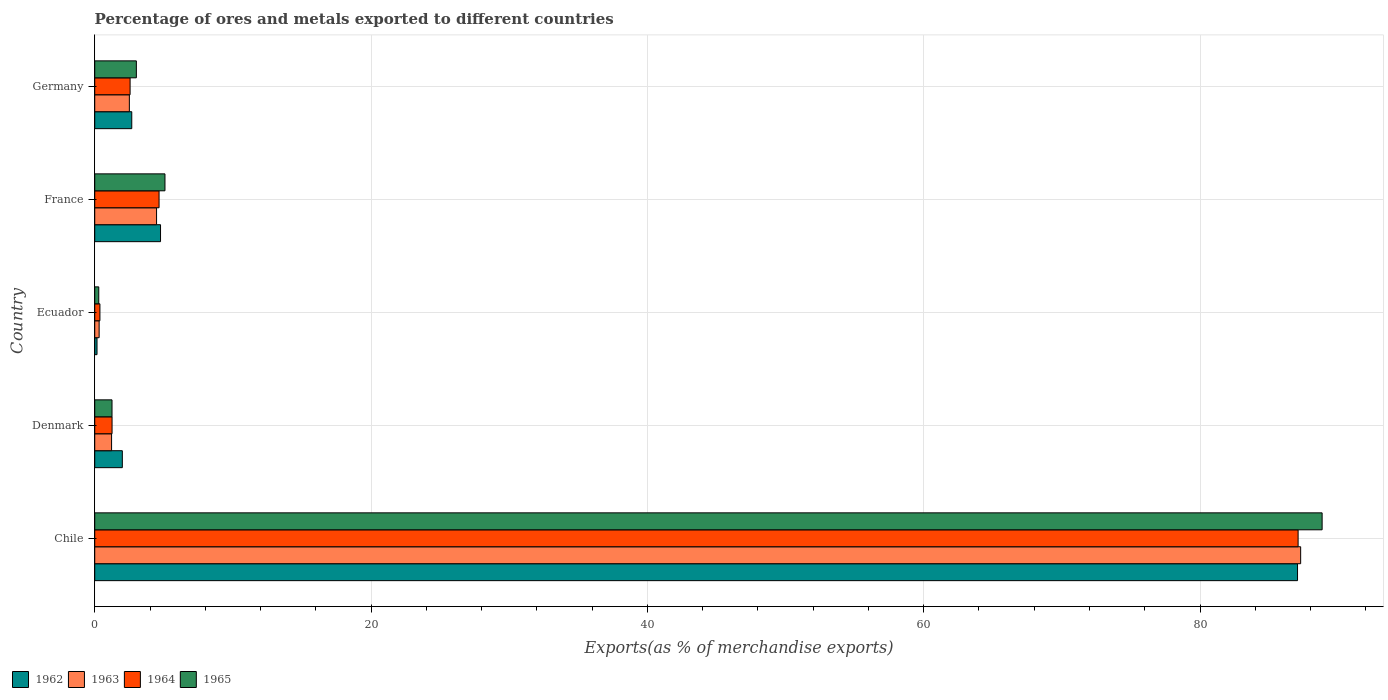Are the number of bars per tick equal to the number of legend labels?
Your response must be concise. Yes. How many bars are there on the 1st tick from the bottom?
Provide a succinct answer. 4. What is the label of the 5th group of bars from the top?
Ensure brevity in your answer.  Chile. In how many cases, is the number of bars for a given country not equal to the number of legend labels?
Make the answer very short. 0. What is the percentage of exports to different countries in 1962 in France?
Your answer should be compact. 4.76. Across all countries, what is the maximum percentage of exports to different countries in 1964?
Your answer should be very brief. 87.1. Across all countries, what is the minimum percentage of exports to different countries in 1964?
Make the answer very short. 0.38. In which country was the percentage of exports to different countries in 1964 minimum?
Keep it short and to the point. Ecuador. What is the total percentage of exports to different countries in 1964 in the graph?
Give a very brief answer. 95.94. What is the difference between the percentage of exports to different countries in 1962 in Denmark and that in Germany?
Ensure brevity in your answer.  -0.68. What is the difference between the percentage of exports to different countries in 1963 in Germany and the percentage of exports to different countries in 1962 in Ecuador?
Offer a terse response. 2.34. What is the average percentage of exports to different countries in 1964 per country?
Ensure brevity in your answer.  19.19. What is the difference between the percentage of exports to different countries in 1964 and percentage of exports to different countries in 1963 in Denmark?
Your answer should be very brief. 0.03. What is the ratio of the percentage of exports to different countries in 1963 in France to that in Germany?
Your answer should be very brief. 1.79. Is the percentage of exports to different countries in 1965 in Ecuador less than that in France?
Provide a succinct answer. Yes. Is the difference between the percentage of exports to different countries in 1964 in Denmark and Germany greater than the difference between the percentage of exports to different countries in 1963 in Denmark and Germany?
Offer a terse response. No. What is the difference between the highest and the second highest percentage of exports to different countries in 1963?
Offer a very short reply. 82.81. What is the difference between the highest and the lowest percentage of exports to different countries in 1962?
Make the answer very short. 86.89. Is it the case that in every country, the sum of the percentage of exports to different countries in 1964 and percentage of exports to different countries in 1962 is greater than the sum of percentage of exports to different countries in 1963 and percentage of exports to different countries in 1965?
Give a very brief answer. No. What does the 4th bar from the top in France represents?
Offer a very short reply. 1962. How many bars are there?
Provide a short and direct response. 20. Are all the bars in the graph horizontal?
Offer a terse response. Yes. Does the graph contain any zero values?
Offer a very short reply. No. How many legend labels are there?
Make the answer very short. 4. What is the title of the graph?
Give a very brief answer. Percentage of ores and metals exported to different countries. What is the label or title of the X-axis?
Provide a short and direct response. Exports(as % of merchandise exports). What is the Exports(as % of merchandise exports) of 1962 in Chile?
Ensure brevity in your answer.  87.06. What is the Exports(as % of merchandise exports) in 1963 in Chile?
Make the answer very short. 87.28. What is the Exports(as % of merchandise exports) of 1964 in Chile?
Your answer should be compact. 87.1. What is the Exports(as % of merchandise exports) of 1965 in Chile?
Your response must be concise. 88.84. What is the Exports(as % of merchandise exports) of 1962 in Denmark?
Your answer should be compact. 2. What is the Exports(as % of merchandise exports) in 1963 in Denmark?
Your answer should be very brief. 1.22. What is the Exports(as % of merchandise exports) of 1964 in Denmark?
Provide a short and direct response. 1.25. What is the Exports(as % of merchandise exports) of 1965 in Denmark?
Your answer should be compact. 1.25. What is the Exports(as % of merchandise exports) of 1962 in Ecuador?
Offer a terse response. 0.17. What is the Exports(as % of merchandise exports) of 1963 in Ecuador?
Give a very brief answer. 0.32. What is the Exports(as % of merchandise exports) of 1964 in Ecuador?
Your answer should be compact. 0.38. What is the Exports(as % of merchandise exports) in 1965 in Ecuador?
Your answer should be compact. 0.29. What is the Exports(as % of merchandise exports) of 1962 in France?
Provide a short and direct response. 4.76. What is the Exports(as % of merchandise exports) of 1963 in France?
Your response must be concise. 4.48. What is the Exports(as % of merchandise exports) in 1964 in France?
Your response must be concise. 4.66. What is the Exports(as % of merchandise exports) of 1965 in France?
Offer a very short reply. 5.08. What is the Exports(as % of merchandise exports) of 1962 in Germany?
Your response must be concise. 2.68. What is the Exports(as % of merchandise exports) of 1963 in Germany?
Make the answer very short. 2.51. What is the Exports(as % of merchandise exports) in 1964 in Germany?
Your answer should be compact. 2.56. What is the Exports(as % of merchandise exports) of 1965 in Germany?
Your answer should be compact. 3.01. Across all countries, what is the maximum Exports(as % of merchandise exports) of 1962?
Your answer should be very brief. 87.06. Across all countries, what is the maximum Exports(as % of merchandise exports) of 1963?
Your answer should be compact. 87.28. Across all countries, what is the maximum Exports(as % of merchandise exports) in 1964?
Provide a succinct answer. 87.1. Across all countries, what is the maximum Exports(as % of merchandise exports) of 1965?
Your response must be concise. 88.84. Across all countries, what is the minimum Exports(as % of merchandise exports) of 1962?
Make the answer very short. 0.17. Across all countries, what is the minimum Exports(as % of merchandise exports) in 1963?
Offer a very short reply. 0.32. Across all countries, what is the minimum Exports(as % of merchandise exports) in 1964?
Keep it short and to the point. 0.38. Across all countries, what is the minimum Exports(as % of merchandise exports) in 1965?
Make the answer very short. 0.29. What is the total Exports(as % of merchandise exports) of 1962 in the graph?
Ensure brevity in your answer.  96.66. What is the total Exports(as % of merchandise exports) of 1963 in the graph?
Provide a succinct answer. 95.8. What is the total Exports(as % of merchandise exports) of 1964 in the graph?
Ensure brevity in your answer.  95.94. What is the total Exports(as % of merchandise exports) of 1965 in the graph?
Provide a succinct answer. 98.47. What is the difference between the Exports(as % of merchandise exports) of 1962 in Chile and that in Denmark?
Offer a terse response. 85.06. What is the difference between the Exports(as % of merchandise exports) in 1963 in Chile and that in Denmark?
Provide a succinct answer. 86.06. What is the difference between the Exports(as % of merchandise exports) of 1964 in Chile and that in Denmark?
Provide a succinct answer. 85.84. What is the difference between the Exports(as % of merchandise exports) in 1965 in Chile and that in Denmark?
Ensure brevity in your answer.  87.58. What is the difference between the Exports(as % of merchandise exports) of 1962 in Chile and that in Ecuador?
Make the answer very short. 86.89. What is the difference between the Exports(as % of merchandise exports) in 1963 in Chile and that in Ecuador?
Provide a succinct answer. 86.96. What is the difference between the Exports(as % of merchandise exports) in 1964 in Chile and that in Ecuador?
Offer a very short reply. 86.72. What is the difference between the Exports(as % of merchandise exports) in 1965 in Chile and that in Ecuador?
Offer a terse response. 88.54. What is the difference between the Exports(as % of merchandise exports) of 1962 in Chile and that in France?
Provide a succinct answer. 82.29. What is the difference between the Exports(as % of merchandise exports) in 1963 in Chile and that in France?
Your response must be concise. 82.81. What is the difference between the Exports(as % of merchandise exports) in 1964 in Chile and that in France?
Give a very brief answer. 82.44. What is the difference between the Exports(as % of merchandise exports) of 1965 in Chile and that in France?
Make the answer very short. 83.75. What is the difference between the Exports(as % of merchandise exports) in 1962 in Chile and that in Germany?
Provide a short and direct response. 84.37. What is the difference between the Exports(as % of merchandise exports) in 1963 in Chile and that in Germany?
Your response must be concise. 84.78. What is the difference between the Exports(as % of merchandise exports) of 1964 in Chile and that in Germany?
Make the answer very short. 84.54. What is the difference between the Exports(as % of merchandise exports) in 1965 in Chile and that in Germany?
Provide a succinct answer. 85.82. What is the difference between the Exports(as % of merchandise exports) of 1962 in Denmark and that in Ecuador?
Your answer should be very brief. 1.83. What is the difference between the Exports(as % of merchandise exports) of 1963 in Denmark and that in Ecuador?
Make the answer very short. 0.9. What is the difference between the Exports(as % of merchandise exports) of 1964 in Denmark and that in Ecuador?
Your answer should be compact. 0.88. What is the difference between the Exports(as % of merchandise exports) of 1965 in Denmark and that in Ecuador?
Give a very brief answer. 0.96. What is the difference between the Exports(as % of merchandise exports) in 1962 in Denmark and that in France?
Give a very brief answer. -2.76. What is the difference between the Exports(as % of merchandise exports) in 1963 in Denmark and that in France?
Ensure brevity in your answer.  -3.26. What is the difference between the Exports(as % of merchandise exports) in 1964 in Denmark and that in France?
Offer a terse response. -3.4. What is the difference between the Exports(as % of merchandise exports) in 1965 in Denmark and that in France?
Ensure brevity in your answer.  -3.83. What is the difference between the Exports(as % of merchandise exports) in 1962 in Denmark and that in Germany?
Make the answer very short. -0.68. What is the difference between the Exports(as % of merchandise exports) of 1963 in Denmark and that in Germany?
Your response must be concise. -1.29. What is the difference between the Exports(as % of merchandise exports) of 1964 in Denmark and that in Germany?
Your response must be concise. -1.31. What is the difference between the Exports(as % of merchandise exports) in 1965 in Denmark and that in Germany?
Ensure brevity in your answer.  -1.76. What is the difference between the Exports(as % of merchandise exports) in 1962 in Ecuador and that in France?
Ensure brevity in your answer.  -4.6. What is the difference between the Exports(as % of merchandise exports) of 1963 in Ecuador and that in France?
Offer a very short reply. -4.16. What is the difference between the Exports(as % of merchandise exports) of 1964 in Ecuador and that in France?
Ensure brevity in your answer.  -4.28. What is the difference between the Exports(as % of merchandise exports) of 1965 in Ecuador and that in France?
Keep it short and to the point. -4.79. What is the difference between the Exports(as % of merchandise exports) in 1962 in Ecuador and that in Germany?
Your answer should be compact. -2.51. What is the difference between the Exports(as % of merchandise exports) in 1963 in Ecuador and that in Germany?
Ensure brevity in your answer.  -2.19. What is the difference between the Exports(as % of merchandise exports) in 1964 in Ecuador and that in Germany?
Your answer should be very brief. -2.18. What is the difference between the Exports(as % of merchandise exports) of 1965 in Ecuador and that in Germany?
Offer a terse response. -2.72. What is the difference between the Exports(as % of merchandise exports) of 1962 in France and that in Germany?
Keep it short and to the point. 2.08. What is the difference between the Exports(as % of merchandise exports) in 1963 in France and that in Germany?
Ensure brevity in your answer.  1.97. What is the difference between the Exports(as % of merchandise exports) in 1964 in France and that in Germany?
Provide a short and direct response. 2.1. What is the difference between the Exports(as % of merchandise exports) in 1965 in France and that in Germany?
Ensure brevity in your answer.  2.07. What is the difference between the Exports(as % of merchandise exports) in 1962 in Chile and the Exports(as % of merchandise exports) in 1963 in Denmark?
Your answer should be compact. 85.84. What is the difference between the Exports(as % of merchandise exports) of 1962 in Chile and the Exports(as % of merchandise exports) of 1964 in Denmark?
Provide a short and direct response. 85.8. What is the difference between the Exports(as % of merchandise exports) of 1962 in Chile and the Exports(as % of merchandise exports) of 1965 in Denmark?
Your response must be concise. 85.8. What is the difference between the Exports(as % of merchandise exports) of 1963 in Chile and the Exports(as % of merchandise exports) of 1964 in Denmark?
Ensure brevity in your answer.  86.03. What is the difference between the Exports(as % of merchandise exports) of 1963 in Chile and the Exports(as % of merchandise exports) of 1965 in Denmark?
Ensure brevity in your answer.  86.03. What is the difference between the Exports(as % of merchandise exports) of 1964 in Chile and the Exports(as % of merchandise exports) of 1965 in Denmark?
Your answer should be compact. 85.85. What is the difference between the Exports(as % of merchandise exports) in 1962 in Chile and the Exports(as % of merchandise exports) in 1963 in Ecuador?
Your answer should be very brief. 86.74. What is the difference between the Exports(as % of merchandise exports) in 1962 in Chile and the Exports(as % of merchandise exports) in 1964 in Ecuador?
Your answer should be compact. 86.68. What is the difference between the Exports(as % of merchandise exports) in 1962 in Chile and the Exports(as % of merchandise exports) in 1965 in Ecuador?
Provide a succinct answer. 86.76. What is the difference between the Exports(as % of merchandise exports) in 1963 in Chile and the Exports(as % of merchandise exports) in 1964 in Ecuador?
Provide a succinct answer. 86.91. What is the difference between the Exports(as % of merchandise exports) in 1963 in Chile and the Exports(as % of merchandise exports) in 1965 in Ecuador?
Keep it short and to the point. 86.99. What is the difference between the Exports(as % of merchandise exports) of 1964 in Chile and the Exports(as % of merchandise exports) of 1965 in Ecuador?
Make the answer very short. 86.81. What is the difference between the Exports(as % of merchandise exports) of 1962 in Chile and the Exports(as % of merchandise exports) of 1963 in France?
Your answer should be compact. 82.58. What is the difference between the Exports(as % of merchandise exports) of 1962 in Chile and the Exports(as % of merchandise exports) of 1964 in France?
Make the answer very short. 82.4. What is the difference between the Exports(as % of merchandise exports) in 1962 in Chile and the Exports(as % of merchandise exports) in 1965 in France?
Provide a succinct answer. 81.97. What is the difference between the Exports(as % of merchandise exports) of 1963 in Chile and the Exports(as % of merchandise exports) of 1964 in France?
Provide a succinct answer. 82.63. What is the difference between the Exports(as % of merchandise exports) of 1963 in Chile and the Exports(as % of merchandise exports) of 1965 in France?
Ensure brevity in your answer.  82.2. What is the difference between the Exports(as % of merchandise exports) in 1964 in Chile and the Exports(as % of merchandise exports) in 1965 in France?
Keep it short and to the point. 82.01. What is the difference between the Exports(as % of merchandise exports) in 1962 in Chile and the Exports(as % of merchandise exports) in 1963 in Germany?
Offer a very short reply. 84.55. What is the difference between the Exports(as % of merchandise exports) of 1962 in Chile and the Exports(as % of merchandise exports) of 1964 in Germany?
Offer a terse response. 84.5. What is the difference between the Exports(as % of merchandise exports) in 1962 in Chile and the Exports(as % of merchandise exports) in 1965 in Germany?
Your response must be concise. 84.04. What is the difference between the Exports(as % of merchandise exports) of 1963 in Chile and the Exports(as % of merchandise exports) of 1964 in Germany?
Ensure brevity in your answer.  84.72. What is the difference between the Exports(as % of merchandise exports) in 1963 in Chile and the Exports(as % of merchandise exports) in 1965 in Germany?
Your response must be concise. 84.27. What is the difference between the Exports(as % of merchandise exports) in 1964 in Chile and the Exports(as % of merchandise exports) in 1965 in Germany?
Provide a short and direct response. 84.08. What is the difference between the Exports(as % of merchandise exports) in 1962 in Denmark and the Exports(as % of merchandise exports) in 1963 in Ecuador?
Keep it short and to the point. 1.68. What is the difference between the Exports(as % of merchandise exports) in 1962 in Denmark and the Exports(as % of merchandise exports) in 1964 in Ecuador?
Your answer should be compact. 1.62. What is the difference between the Exports(as % of merchandise exports) in 1962 in Denmark and the Exports(as % of merchandise exports) in 1965 in Ecuador?
Offer a very short reply. 1.71. What is the difference between the Exports(as % of merchandise exports) in 1963 in Denmark and the Exports(as % of merchandise exports) in 1964 in Ecuador?
Offer a terse response. 0.84. What is the difference between the Exports(as % of merchandise exports) in 1963 in Denmark and the Exports(as % of merchandise exports) in 1965 in Ecuador?
Offer a terse response. 0.93. What is the difference between the Exports(as % of merchandise exports) of 1964 in Denmark and the Exports(as % of merchandise exports) of 1965 in Ecuador?
Give a very brief answer. 0.96. What is the difference between the Exports(as % of merchandise exports) in 1962 in Denmark and the Exports(as % of merchandise exports) in 1963 in France?
Keep it short and to the point. -2.48. What is the difference between the Exports(as % of merchandise exports) of 1962 in Denmark and the Exports(as % of merchandise exports) of 1964 in France?
Ensure brevity in your answer.  -2.66. What is the difference between the Exports(as % of merchandise exports) of 1962 in Denmark and the Exports(as % of merchandise exports) of 1965 in France?
Ensure brevity in your answer.  -3.09. What is the difference between the Exports(as % of merchandise exports) in 1963 in Denmark and the Exports(as % of merchandise exports) in 1964 in France?
Provide a succinct answer. -3.44. What is the difference between the Exports(as % of merchandise exports) in 1963 in Denmark and the Exports(as % of merchandise exports) in 1965 in France?
Give a very brief answer. -3.86. What is the difference between the Exports(as % of merchandise exports) in 1964 in Denmark and the Exports(as % of merchandise exports) in 1965 in France?
Keep it short and to the point. -3.83. What is the difference between the Exports(as % of merchandise exports) in 1962 in Denmark and the Exports(as % of merchandise exports) in 1963 in Germany?
Provide a short and direct response. -0.51. What is the difference between the Exports(as % of merchandise exports) of 1962 in Denmark and the Exports(as % of merchandise exports) of 1964 in Germany?
Your answer should be compact. -0.56. What is the difference between the Exports(as % of merchandise exports) in 1962 in Denmark and the Exports(as % of merchandise exports) in 1965 in Germany?
Your answer should be compact. -1.02. What is the difference between the Exports(as % of merchandise exports) in 1963 in Denmark and the Exports(as % of merchandise exports) in 1964 in Germany?
Your answer should be compact. -1.34. What is the difference between the Exports(as % of merchandise exports) in 1963 in Denmark and the Exports(as % of merchandise exports) in 1965 in Germany?
Your response must be concise. -1.79. What is the difference between the Exports(as % of merchandise exports) in 1964 in Denmark and the Exports(as % of merchandise exports) in 1965 in Germany?
Provide a succinct answer. -1.76. What is the difference between the Exports(as % of merchandise exports) of 1962 in Ecuador and the Exports(as % of merchandise exports) of 1963 in France?
Provide a short and direct response. -4.31. What is the difference between the Exports(as % of merchandise exports) of 1962 in Ecuador and the Exports(as % of merchandise exports) of 1964 in France?
Keep it short and to the point. -4.49. What is the difference between the Exports(as % of merchandise exports) of 1962 in Ecuador and the Exports(as % of merchandise exports) of 1965 in France?
Your response must be concise. -4.92. What is the difference between the Exports(as % of merchandise exports) in 1963 in Ecuador and the Exports(as % of merchandise exports) in 1964 in France?
Offer a very short reply. -4.34. What is the difference between the Exports(as % of merchandise exports) of 1963 in Ecuador and the Exports(as % of merchandise exports) of 1965 in France?
Keep it short and to the point. -4.76. What is the difference between the Exports(as % of merchandise exports) of 1964 in Ecuador and the Exports(as % of merchandise exports) of 1965 in France?
Keep it short and to the point. -4.71. What is the difference between the Exports(as % of merchandise exports) in 1962 in Ecuador and the Exports(as % of merchandise exports) in 1963 in Germany?
Provide a succinct answer. -2.34. What is the difference between the Exports(as % of merchandise exports) in 1962 in Ecuador and the Exports(as % of merchandise exports) in 1964 in Germany?
Ensure brevity in your answer.  -2.39. What is the difference between the Exports(as % of merchandise exports) of 1962 in Ecuador and the Exports(as % of merchandise exports) of 1965 in Germany?
Provide a short and direct response. -2.85. What is the difference between the Exports(as % of merchandise exports) of 1963 in Ecuador and the Exports(as % of merchandise exports) of 1964 in Germany?
Offer a terse response. -2.24. What is the difference between the Exports(as % of merchandise exports) in 1963 in Ecuador and the Exports(as % of merchandise exports) in 1965 in Germany?
Provide a succinct answer. -2.69. What is the difference between the Exports(as % of merchandise exports) of 1964 in Ecuador and the Exports(as % of merchandise exports) of 1965 in Germany?
Offer a terse response. -2.64. What is the difference between the Exports(as % of merchandise exports) in 1962 in France and the Exports(as % of merchandise exports) in 1963 in Germany?
Keep it short and to the point. 2.26. What is the difference between the Exports(as % of merchandise exports) in 1962 in France and the Exports(as % of merchandise exports) in 1964 in Germany?
Give a very brief answer. 2.2. What is the difference between the Exports(as % of merchandise exports) of 1962 in France and the Exports(as % of merchandise exports) of 1965 in Germany?
Make the answer very short. 1.75. What is the difference between the Exports(as % of merchandise exports) in 1963 in France and the Exports(as % of merchandise exports) in 1964 in Germany?
Your response must be concise. 1.92. What is the difference between the Exports(as % of merchandise exports) in 1963 in France and the Exports(as % of merchandise exports) in 1965 in Germany?
Offer a terse response. 1.46. What is the difference between the Exports(as % of merchandise exports) of 1964 in France and the Exports(as % of merchandise exports) of 1965 in Germany?
Provide a short and direct response. 1.64. What is the average Exports(as % of merchandise exports) in 1962 per country?
Offer a terse response. 19.33. What is the average Exports(as % of merchandise exports) in 1963 per country?
Keep it short and to the point. 19.16. What is the average Exports(as % of merchandise exports) in 1964 per country?
Provide a short and direct response. 19.19. What is the average Exports(as % of merchandise exports) in 1965 per country?
Your answer should be very brief. 19.7. What is the difference between the Exports(as % of merchandise exports) of 1962 and Exports(as % of merchandise exports) of 1963 in Chile?
Your answer should be compact. -0.23. What is the difference between the Exports(as % of merchandise exports) of 1962 and Exports(as % of merchandise exports) of 1964 in Chile?
Ensure brevity in your answer.  -0.04. What is the difference between the Exports(as % of merchandise exports) in 1962 and Exports(as % of merchandise exports) in 1965 in Chile?
Your response must be concise. -1.78. What is the difference between the Exports(as % of merchandise exports) of 1963 and Exports(as % of merchandise exports) of 1964 in Chile?
Offer a very short reply. 0.18. What is the difference between the Exports(as % of merchandise exports) of 1963 and Exports(as % of merchandise exports) of 1965 in Chile?
Your answer should be very brief. -1.55. What is the difference between the Exports(as % of merchandise exports) of 1964 and Exports(as % of merchandise exports) of 1965 in Chile?
Make the answer very short. -1.74. What is the difference between the Exports(as % of merchandise exports) of 1962 and Exports(as % of merchandise exports) of 1963 in Denmark?
Your answer should be very brief. 0.78. What is the difference between the Exports(as % of merchandise exports) of 1962 and Exports(as % of merchandise exports) of 1964 in Denmark?
Your answer should be compact. 0.74. What is the difference between the Exports(as % of merchandise exports) in 1962 and Exports(as % of merchandise exports) in 1965 in Denmark?
Provide a short and direct response. 0.75. What is the difference between the Exports(as % of merchandise exports) in 1963 and Exports(as % of merchandise exports) in 1964 in Denmark?
Provide a short and direct response. -0.03. What is the difference between the Exports(as % of merchandise exports) in 1963 and Exports(as % of merchandise exports) in 1965 in Denmark?
Your answer should be very brief. -0.03. What is the difference between the Exports(as % of merchandise exports) of 1964 and Exports(as % of merchandise exports) of 1965 in Denmark?
Offer a very short reply. 0. What is the difference between the Exports(as % of merchandise exports) of 1962 and Exports(as % of merchandise exports) of 1963 in Ecuador?
Your answer should be compact. -0.15. What is the difference between the Exports(as % of merchandise exports) of 1962 and Exports(as % of merchandise exports) of 1964 in Ecuador?
Keep it short and to the point. -0.21. What is the difference between the Exports(as % of merchandise exports) in 1962 and Exports(as % of merchandise exports) in 1965 in Ecuador?
Make the answer very short. -0.13. What is the difference between the Exports(as % of merchandise exports) of 1963 and Exports(as % of merchandise exports) of 1964 in Ecuador?
Give a very brief answer. -0.06. What is the difference between the Exports(as % of merchandise exports) in 1963 and Exports(as % of merchandise exports) in 1965 in Ecuador?
Keep it short and to the point. 0.03. What is the difference between the Exports(as % of merchandise exports) of 1964 and Exports(as % of merchandise exports) of 1965 in Ecuador?
Keep it short and to the point. 0.08. What is the difference between the Exports(as % of merchandise exports) in 1962 and Exports(as % of merchandise exports) in 1963 in France?
Your answer should be compact. 0.29. What is the difference between the Exports(as % of merchandise exports) in 1962 and Exports(as % of merchandise exports) in 1964 in France?
Give a very brief answer. 0.11. What is the difference between the Exports(as % of merchandise exports) in 1962 and Exports(as % of merchandise exports) in 1965 in France?
Offer a terse response. -0.32. What is the difference between the Exports(as % of merchandise exports) in 1963 and Exports(as % of merchandise exports) in 1964 in France?
Your response must be concise. -0.18. What is the difference between the Exports(as % of merchandise exports) in 1963 and Exports(as % of merchandise exports) in 1965 in France?
Offer a terse response. -0.61. What is the difference between the Exports(as % of merchandise exports) of 1964 and Exports(as % of merchandise exports) of 1965 in France?
Offer a terse response. -0.43. What is the difference between the Exports(as % of merchandise exports) in 1962 and Exports(as % of merchandise exports) in 1963 in Germany?
Keep it short and to the point. 0.17. What is the difference between the Exports(as % of merchandise exports) in 1962 and Exports(as % of merchandise exports) in 1964 in Germany?
Give a very brief answer. 0.12. What is the difference between the Exports(as % of merchandise exports) of 1962 and Exports(as % of merchandise exports) of 1965 in Germany?
Provide a short and direct response. -0.33. What is the difference between the Exports(as % of merchandise exports) of 1963 and Exports(as % of merchandise exports) of 1964 in Germany?
Provide a short and direct response. -0.05. What is the difference between the Exports(as % of merchandise exports) of 1963 and Exports(as % of merchandise exports) of 1965 in Germany?
Your answer should be compact. -0.51. What is the difference between the Exports(as % of merchandise exports) of 1964 and Exports(as % of merchandise exports) of 1965 in Germany?
Provide a succinct answer. -0.45. What is the ratio of the Exports(as % of merchandise exports) in 1962 in Chile to that in Denmark?
Your answer should be very brief. 43.58. What is the ratio of the Exports(as % of merchandise exports) in 1963 in Chile to that in Denmark?
Your response must be concise. 71.57. What is the ratio of the Exports(as % of merchandise exports) of 1964 in Chile to that in Denmark?
Ensure brevity in your answer.  69.44. What is the ratio of the Exports(as % of merchandise exports) of 1965 in Chile to that in Denmark?
Provide a succinct answer. 71. What is the ratio of the Exports(as % of merchandise exports) in 1962 in Chile to that in Ecuador?
Keep it short and to the point. 525.05. What is the ratio of the Exports(as % of merchandise exports) in 1963 in Chile to that in Ecuador?
Give a very brief answer. 273.43. What is the ratio of the Exports(as % of merchandise exports) of 1964 in Chile to that in Ecuador?
Offer a terse response. 231.84. What is the ratio of the Exports(as % of merchandise exports) of 1965 in Chile to that in Ecuador?
Provide a succinct answer. 304.49. What is the ratio of the Exports(as % of merchandise exports) in 1962 in Chile to that in France?
Provide a succinct answer. 18.28. What is the ratio of the Exports(as % of merchandise exports) of 1963 in Chile to that in France?
Your answer should be very brief. 19.5. What is the ratio of the Exports(as % of merchandise exports) of 1964 in Chile to that in France?
Provide a succinct answer. 18.71. What is the ratio of the Exports(as % of merchandise exports) of 1965 in Chile to that in France?
Offer a terse response. 17.47. What is the ratio of the Exports(as % of merchandise exports) in 1962 in Chile to that in Germany?
Ensure brevity in your answer.  32.48. What is the ratio of the Exports(as % of merchandise exports) in 1963 in Chile to that in Germany?
Your response must be concise. 34.83. What is the ratio of the Exports(as % of merchandise exports) in 1964 in Chile to that in Germany?
Provide a short and direct response. 34.03. What is the ratio of the Exports(as % of merchandise exports) of 1965 in Chile to that in Germany?
Give a very brief answer. 29.48. What is the ratio of the Exports(as % of merchandise exports) of 1962 in Denmark to that in Ecuador?
Keep it short and to the point. 12.05. What is the ratio of the Exports(as % of merchandise exports) in 1963 in Denmark to that in Ecuador?
Keep it short and to the point. 3.82. What is the ratio of the Exports(as % of merchandise exports) of 1964 in Denmark to that in Ecuador?
Ensure brevity in your answer.  3.34. What is the ratio of the Exports(as % of merchandise exports) of 1965 in Denmark to that in Ecuador?
Provide a succinct answer. 4.29. What is the ratio of the Exports(as % of merchandise exports) of 1962 in Denmark to that in France?
Make the answer very short. 0.42. What is the ratio of the Exports(as % of merchandise exports) of 1963 in Denmark to that in France?
Provide a succinct answer. 0.27. What is the ratio of the Exports(as % of merchandise exports) of 1964 in Denmark to that in France?
Your answer should be compact. 0.27. What is the ratio of the Exports(as % of merchandise exports) of 1965 in Denmark to that in France?
Provide a short and direct response. 0.25. What is the ratio of the Exports(as % of merchandise exports) of 1962 in Denmark to that in Germany?
Provide a succinct answer. 0.75. What is the ratio of the Exports(as % of merchandise exports) of 1963 in Denmark to that in Germany?
Ensure brevity in your answer.  0.49. What is the ratio of the Exports(as % of merchandise exports) of 1964 in Denmark to that in Germany?
Your answer should be compact. 0.49. What is the ratio of the Exports(as % of merchandise exports) of 1965 in Denmark to that in Germany?
Your response must be concise. 0.42. What is the ratio of the Exports(as % of merchandise exports) of 1962 in Ecuador to that in France?
Provide a succinct answer. 0.03. What is the ratio of the Exports(as % of merchandise exports) of 1963 in Ecuador to that in France?
Give a very brief answer. 0.07. What is the ratio of the Exports(as % of merchandise exports) in 1964 in Ecuador to that in France?
Your answer should be compact. 0.08. What is the ratio of the Exports(as % of merchandise exports) in 1965 in Ecuador to that in France?
Your response must be concise. 0.06. What is the ratio of the Exports(as % of merchandise exports) in 1962 in Ecuador to that in Germany?
Your answer should be very brief. 0.06. What is the ratio of the Exports(as % of merchandise exports) in 1963 in Ecuador to that in Germany?
Your response must be concise. 0.13. What is the ratio of the Exports(as % of merchandise exports) of 1964 in Ecuador to that in Germany?
Keep it short and to the point. 0.15. What is the ratio of the Exports(as % of merchandise exports) in 1965 in Ecuador to that in Germany?
Make the answer very short. 0.1. What is the ratio of the Exports(as % of merchandise exports) in 1962 in France to that in Germany?
Make the answer very short. 1.78. What is the ratio of the Exports(as % of merchandise exports) in 1963 in France to that in Germany?
Your response must be concise. 1.79. What is the ratio of the Exports(as % of merchandise exports) of 1964 in France to that in Germany?
Provide a succinct answer. 1.82. What is the ratio of the Exports(as % of merchandise exports) in 1965 in France to that in Germany?
Keep it short and to the point. 1.69. What is the difference between the highest and the second highest Exports(as % of merchandise exports) of 1962?
Provide a short and direct response. 82.29. What is the difference between the highest and the second highest Exports(as % of merchandise exports) in 1963?
Offer a terse response. 82.81. What is the difference between the highest and the second highest Exports(as % of merchandise exports) of 1964?
Your answer should be very brief. 82.44. What is the difference between the highest and the second highest Exports(as % of merchandise exports) in 1965?
Ensure brevity in your answer.  83.75. What is the difference between the highest and the lowest Exports(as % of merchandise exports) in 1962?
Your response must be concise. 86.89. What is the difference between the highest and the lowest Exports(as % of merchandise exports) in 1963?
Offer a terse response. 86.96. What is the difference between the highest and the lowest Exports(as % of merchandise exports) of 1964?
Your answer should be very brief. 86.72. What is the difference between the highest and the lowest Exports(as % of merchandise exports) of 1965?
Ensure brevity in your answer.  88.54. 